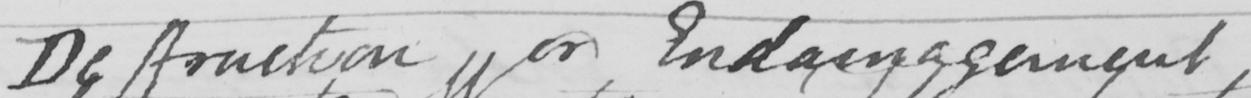Please transcribe the handwritten text in this image. Destruction or Endamagement . 